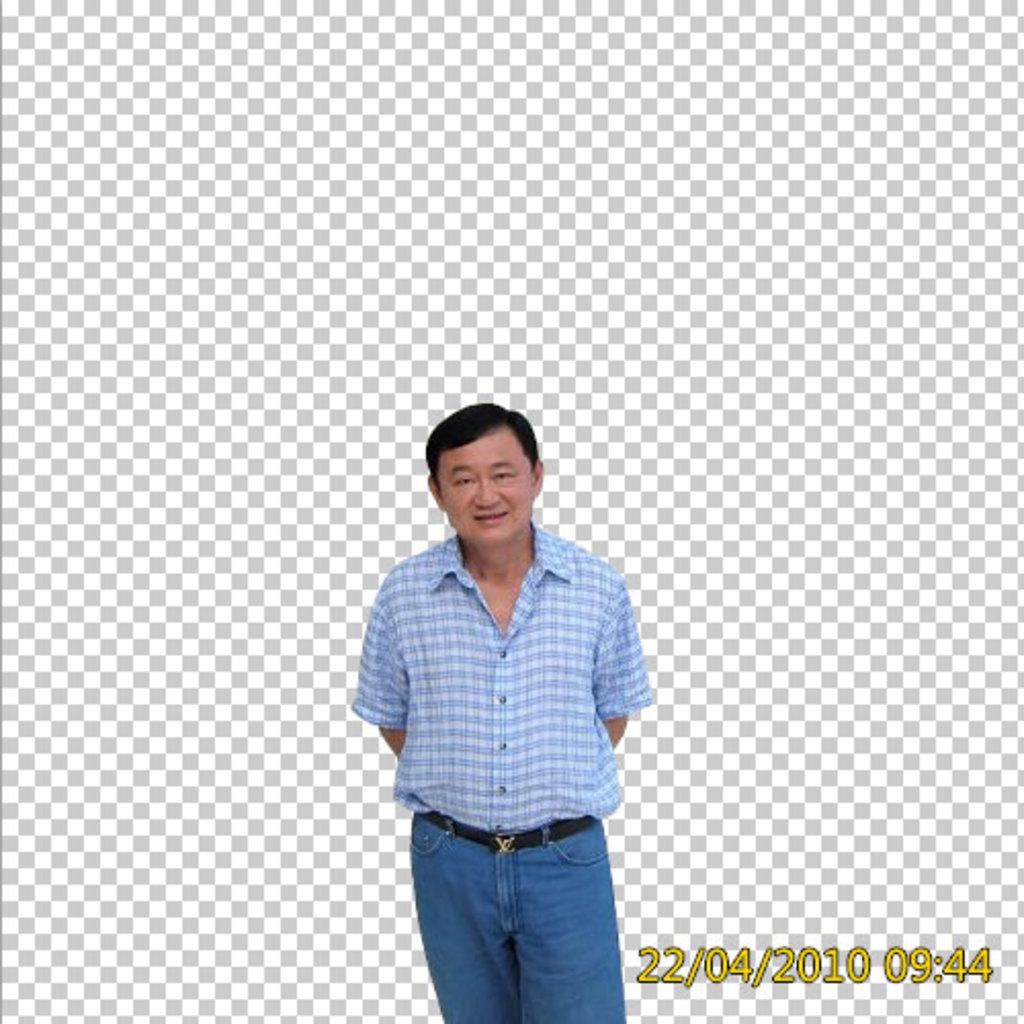What is present in the image? There is a person in the image. What is the person wearing? The person is wearing a white and blue color shirt and blue color pants. What can be observed about the background of the image? The background of the image is white and gray in color. What type of quince is the person holding in the image? There is no quince present in the image. Is the person wearing a hat in the image? The provided facts do not mention a hat, so we cannot determine if the person is wearing one. 